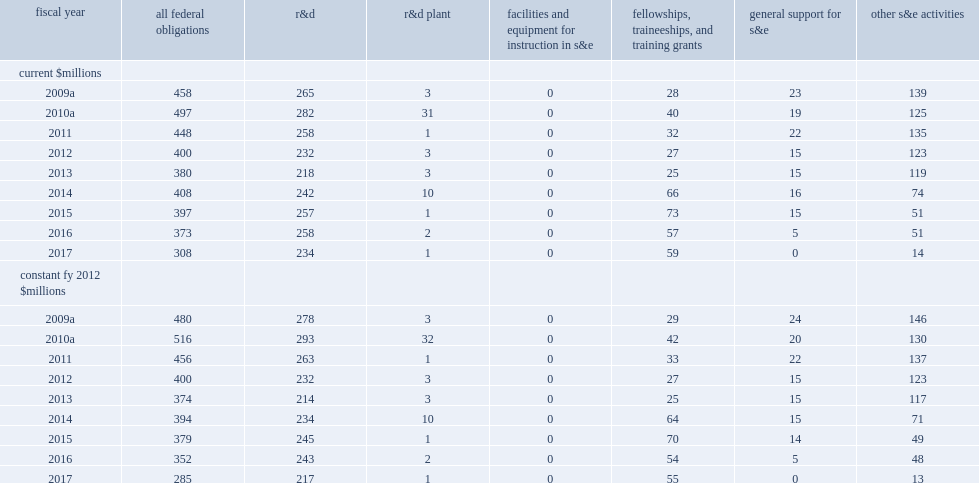How many billion dollars did total s&e support to historically black colleges and universities (hbcus) decline for the third year in a row? 308.0. How many percentage points did total s&e support to historically black colleges and universities (hbcus) decline for the third year in a row down from fy 2016? -0.174263. 